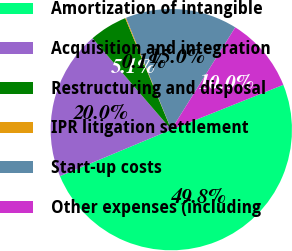Convert chart. <chart><loc_0><loc_0><loc_500><loc_500><pie_chart><fcel>Amortization of intangible<fcel>Acquisition and integration<fcel>Restructuring and disposal<fcel>IPR litigation settlement<fcel>Start-up costs<fcel>Other expenses (including<nl><fcel>49.76%<fcel>19.98%<fcel>5.08%<fcel>0.12%<fcel>15.01%<fcel>10.05%<nl></chart> 